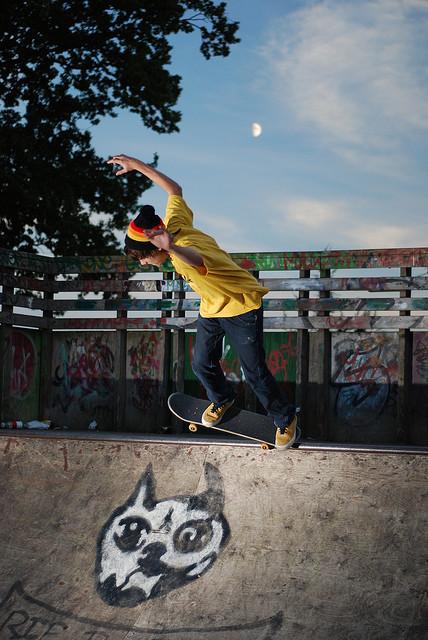Is it night?
Give a very brief answer. Yes. Has this person taken any safety precautions?
Be succinct. No. Is this boy having fun?
Concise answer only. Yes. 